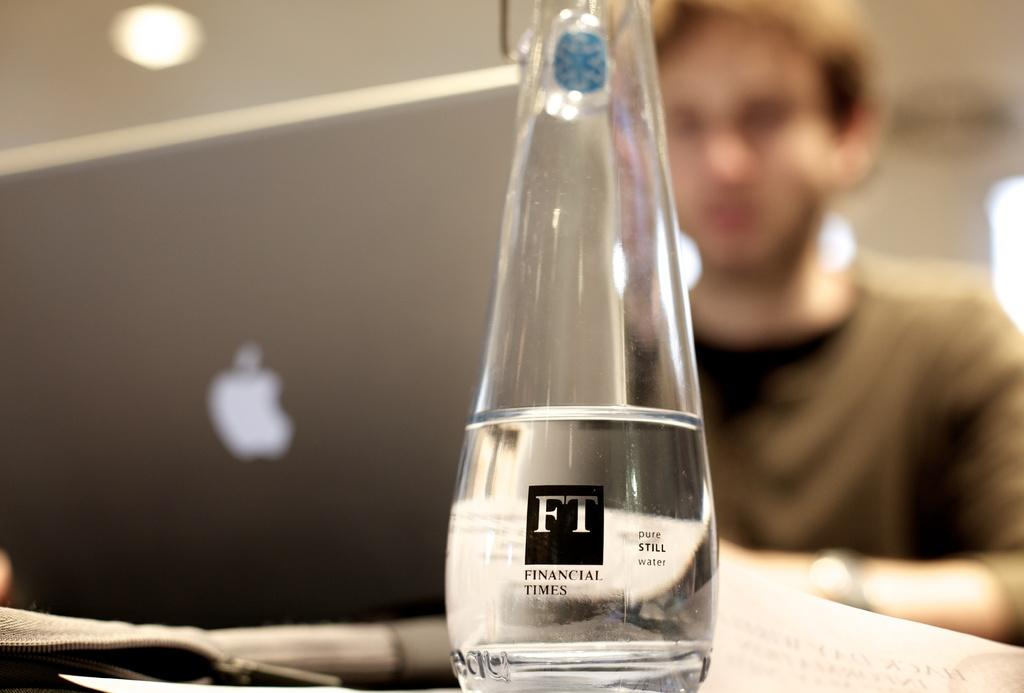<image>
Provide a brief description of the given image. A bottle of half drunken Financial Times pure still water has been placed on the desk 